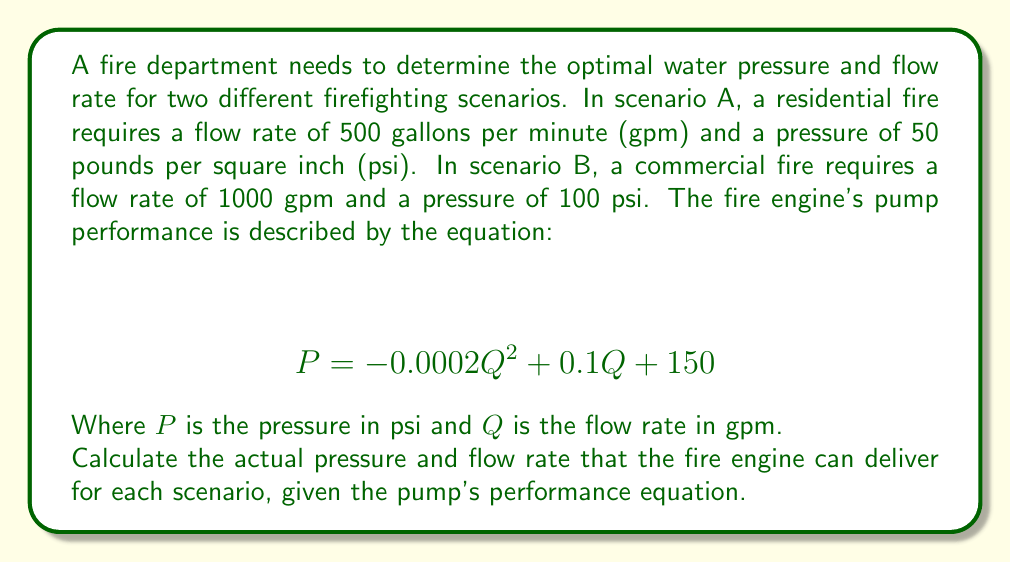Can you solve this math problem? To solve this problem, we need to use the given pump performance equation and the requirements for each scenario. We'll solve the equation for each scenario separately.

Scenario A (Residential Fire):
Required: 500 gpm at 50 psi

Let's substitute Q = 500 into the pump performance equation:

$$ P = -0.0002(500)^2 + 0.1(500) + 150 $$
$$ P = -0.0002(250000) + 50 + 150 $$
$$ P = -50 + 50 + 150 $$
$$ P = 150 \text{ psi} $$

The pump can deliver 150 psi at 500 gpm, which exceeds the required 50 psi. Therefore, the actual delivery for Scenario A will be 500 gpm at 50 psi, as the pressure can be regulated down to meet the requirement.

Scenario B (Commercial Fire):
Required: 1000 gpm at 100 psi

Let's substitute Q = 1000 into the pump performance equation:

$$ P = -0.0002(1000)^2 + 0.1(1000) + 150 $$
$$ P = -0.0002(1000000) + 100 + 150 $$
$$ P = -200 + 100 + 150 $$
$$ P = 50 \text{ psi} $$

The pump can only deliver 50 psi at 1000 gpm, which is less than the required 100 psi. We need to find the flow rate at which the pump can deliver 100 psi. We can do this by solving the quadratic equation:

$$ 100 = -0.0002Q^2 + 0.1Q + 150 $$
$$ 0 = -0.0002Q^2 + 0.1Q + 50 $$
$$ 0.0002Q^2 - 0.1Q - 50 = 0 $$

Using the quadratic formula, $Q = \frac{-b \pm \sqrt{b^2 - 4ac}}{2a}$, we get:

$$ Q = \frac{0.1 \pm \sqrt{0.01 - 4(0.0002)(-50)}}{2(0.0002)} $$
$$ Q = \frac{0.1 \pm \sqrt{0.01 + 0.04}}{0.0004} $$
$$ Q = \frac{0.1 \pm \sqrt{0.05}}{0.0004} $$
$$ Q = \frac{0.1 \pm 0.2236}{0.0004} $$

Taking the positive root:
$$ Q = \frac{0.1 + 0.2236}{0.0004} \approx 809.02 \text{ gpm} $$

Therefore, for Scenario B, the fire engine can deliver 100 psi at approximately 809 gpm.
Answer: Scenario A: 500 gpm at 50 psi
Scenario B: 809 gpm at 100 psi 